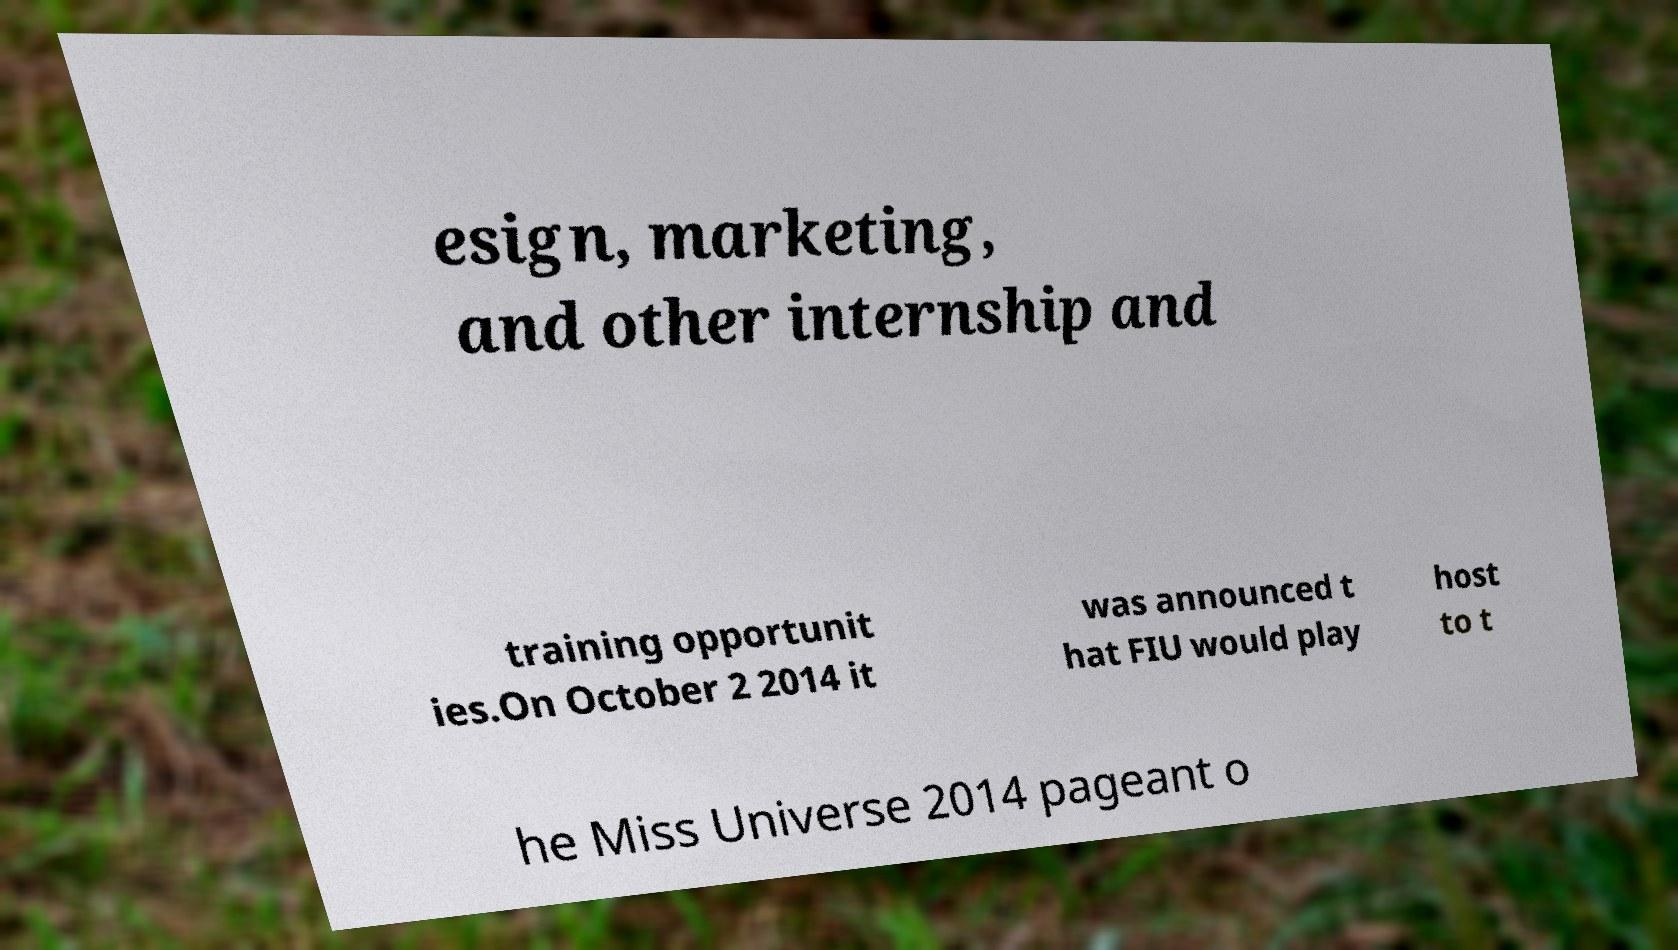I need the written content from this picture converted into text. Can you do that? esign, marketing, and other internship and training opportunit ies.On October 2 2014 it was announced t hat FIU would play host to t he Miss Universe 2014 pageant o 